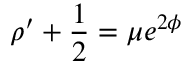<formula> <loc_0><loc_0><loc_500><loc_500>\rho ^ { \prime } + \frac { 1 } { 2 } = \mu e ^ { 2 \phi }</formula> 